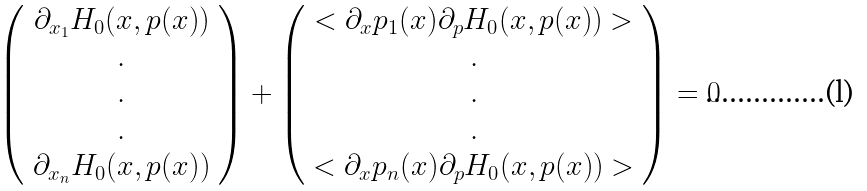<formula> <loc_0><loc_0><loc_500><loc_500>\left ( \begin{array} { c } \partial _ { x _ { 1 } } H _ { 0 } ( x , p ( x ) ) \\ . \\ . \\ . \\ \partial _ { x _ { n } } H _ { 0 } ( x , p ( x ) ) \\ \end{array} \right ) + \left ( \begin{array} { c } < \partial _ { x } p _ { 1 } ( x ) \partial _ { p } H _ { 0 } ( x , p ( x ) ) > \\ . \\ . \\ . \\ < \partial _ { x } p _ { n } ( x ) \partial _ { p } H _ { 0 } ( x , p ( x ) ) > \\ \end{array} \right ) = 0</formula> 